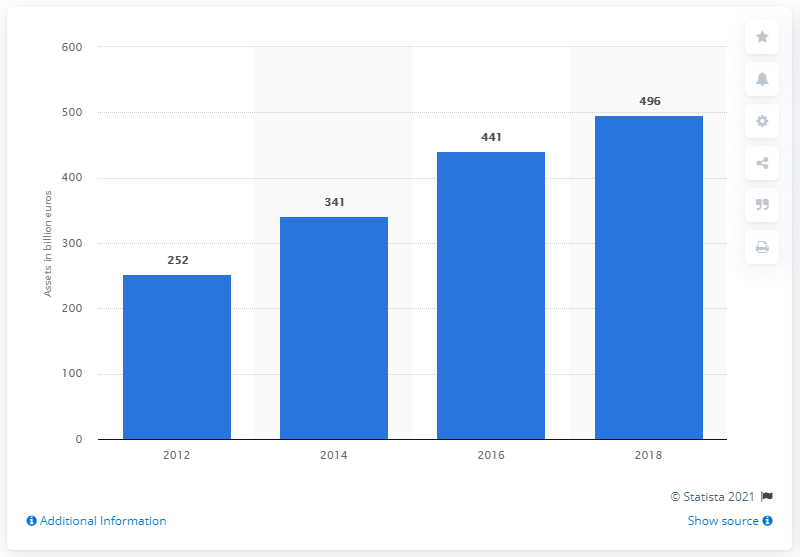Highlight a few significant elements in this photo. The total value of RI funds managed in Europe in 2012 was approximately 252 million dollars. As of the end of 2018, the total value of assets under management on the responsible investing market was approximately 496. 